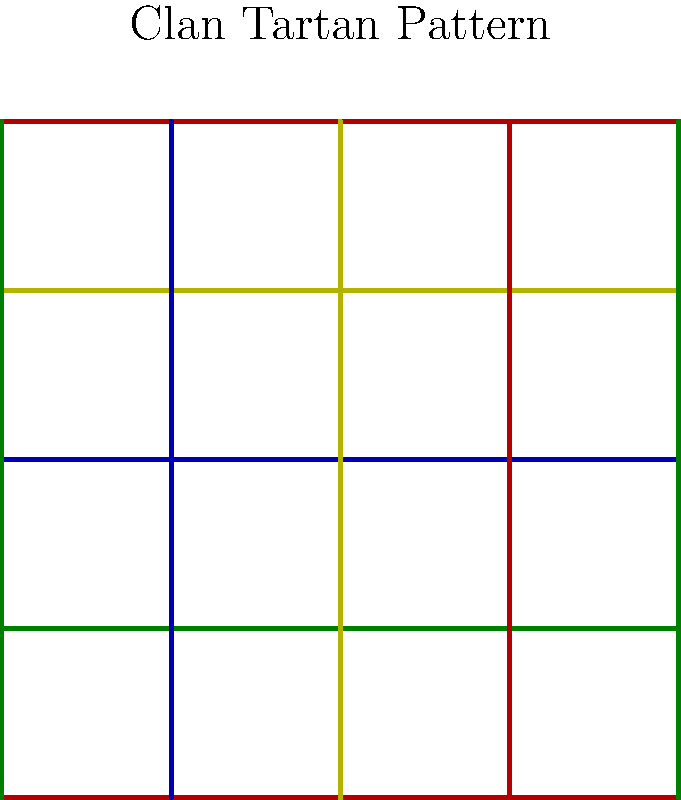In the context of group theory, consider the symmetries of the Scottish clan tartan pattern shown above. Which group best describes the symmetry operations that leave this pattern unchanged, and how does this relate to the historical significance of clan tartans in Scottish culture? To answer this question, let's analyze the tartan pattern step-by-step:

1. Observe the pattern: The tartan consists of perpendicular lines forming a grid, with repeating color sequences both horizontally and vertically.

2. Identify symmetry operations:
   a) Translation: The pattern repeats when shifted horizontally or vertically by the width of one complete color sequence.
   b) Rotation: The pattern remains unchanged when rotated 180° around the center of any square.
   c) Reflection: The pattern is symmetric when reflected across horizontal or vertical lines through the center of any square.

3. Determine the group structure:
   These symmetry operations form a wallpaper group, specifically the p4m group. This group includes:
   - Four-fold rotational symmetry (90°, 180°, 270°, 360°)
   - Reflections across horizontal, vertical, and diagonal lines
   - Translations in two perpendicular directions

4. Historical context:
   Clan tartans emerged as identifiers in the late 18th century, symbolizing family unity and cultural identity. The symmetry group p4m reflects this unity through its structured, repeating pattern.

5. Cultural significance:
   The rigid symmetry of tartans aligns with the hierarchical clan structure and the importance of lineage in Scottish society. The group theoretical approach to analyzing tartans provides insight into how mathematical concepts can be applied to cultural artifacts.

6. Reformation impact:
   The standardization and registration of clan tartans in the 19th century can be seen as a response to the disruption of traditional Highland culture following the Reformation and later political events. The mathematical regularity of tartan patterns may reflect a desire for order and identity in a changing society.
Answer: p4m wallpaper group 